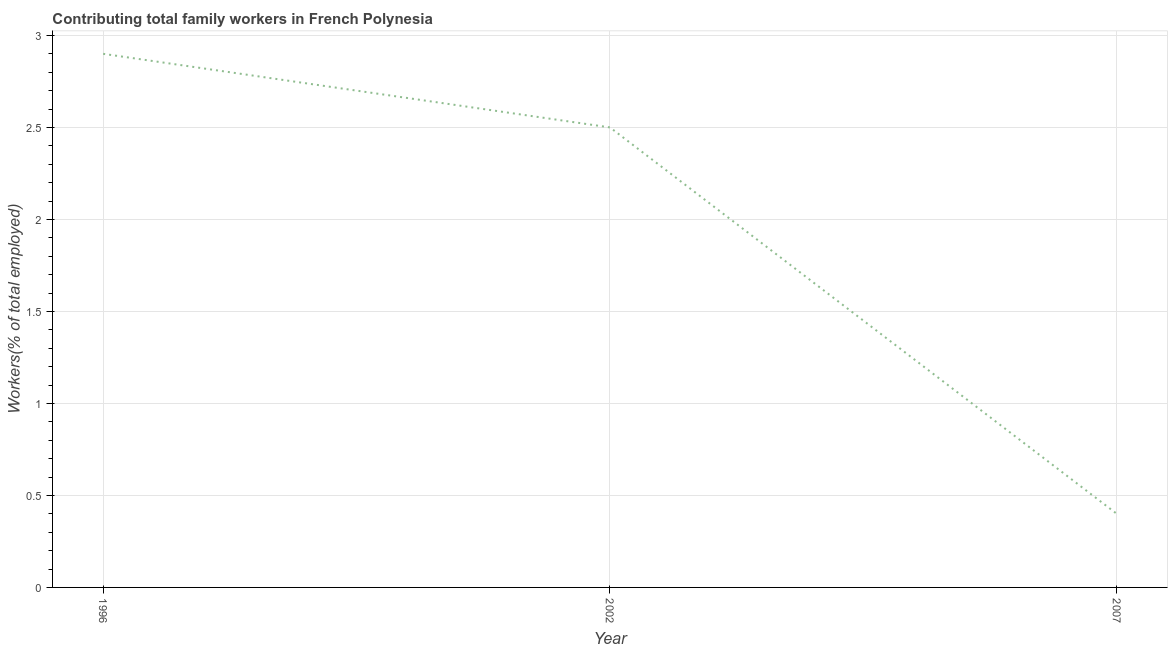What is the contributing family workers in 1996?
Give a very brief answer. 2.9. Across all years, what is the maximum contributing family workers?
Ensure brevity in your answer.  2.9. Across all years, what is the minimum contributing family workers?
Make the answer very short. 0.4. In which year was the contributing family workers maximum?
Your answer should be very brief. 1996. In which year was the contributing family workers minimum?
Give a very brief answer. 2007. What is the sum of the contributing family workers?
Offer a very short reply. 5.8. What is the difference between the contributing family workers in 1996 and 2002?
Ensure brevity in your answer.  0.4. What is the average contributing family workers per year?
Your response must be concise. 1.93. What is the median contributing family workers?
Keep it short and to the point. 2.5. Do a majority of the years between 1996 and 2007 (inclusive) have contributing family workers greater than 1.6 %?
Your response must be concise. Yes. What is the ratio of the contributing family workers in 1996 to that in 2002?
Provide a succinct answer. 1.16. Is the contributing family workers in 2002 less than that in 2007?
Ensure brevity in your answer.  No. Is the difference between the contributing family workers in 2002 and 2007 greater than the difference between any two years?
Your answer should be compact. No. What is the difference between the highest and the second highest contributing family workers?
Offer a very short reply. 0.4. What is the difference between the highest and the lowest contributing family workers?
Your answer should be very brief. 2.5. In how many years, is the contributing family workers greater than the average contributing family workers taken over all years?
Give a very brief answer. 2. How many lines are there?
Your answer should be very brief. 1. How many years are there in the graph?
Offer a terse response. 3. What is the difference between two consecutive major ticks on the Y-axis?
Make the answer very short. 0.5. Are the values on the major ticks of Y-axis written in scientific E-notation?
Offer a very short reply. No. Does the graph contain any zero values?
Provide a short and direct response. No. What is the title of the graph?
Provide a succinct answer. Contributing total family workers in French Polynesia. What is the label or title of the Y-axis?
Your answer should be compact. Workers(% of total employed). What is the Workers(% of total employed) of 1996?
Offer a terse response. 2.9. What is the Workers(% of total employed) in 2007?
Provide a short and direct response. 0.4. What is the ratio of the Workers(% of total employed) in 1996 to that in 2002?
Provide a succinct answer. 1.16. What is the ratio of the Workers(% of total employed) in 1996 to that in 2007?
Your answer should be very brief. 7.25. What is the ratio of the Workers(% of total employed) in 2002 to that in 2007?
Your answer should be compact. 6.25. 